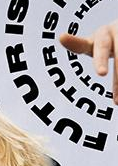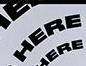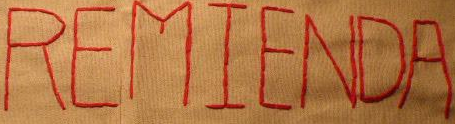What words are shown in these images in order, separated by a semicolon? FUTURIS; HERE; REMIENDA 